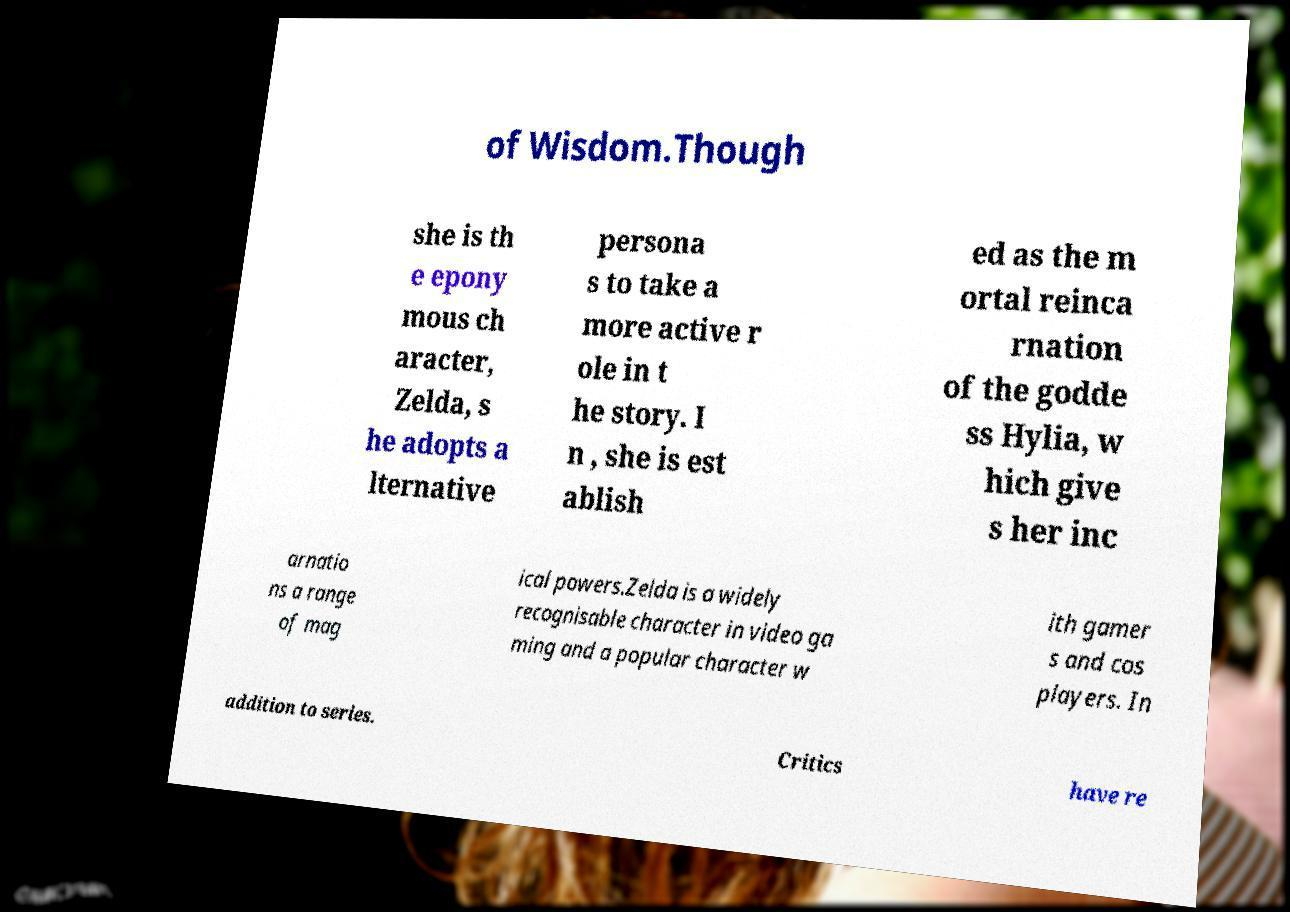Please identify and transcribe the text found in this image. of Wisdom.Though she is th e epony mous ch aracter, Zelda, s he adopts a lternative persona s to take a more active r ole in t he story. I n , she is est ablish ed as the m ortal reinca rnation of the godde ss Hylia, w hich give s her inc arnatio ns a range of mag ical powers.Zelda is a widely recognisable character in video ga ming and a popular character w ith gamer s and cos players. In addition to series. Critics have re 